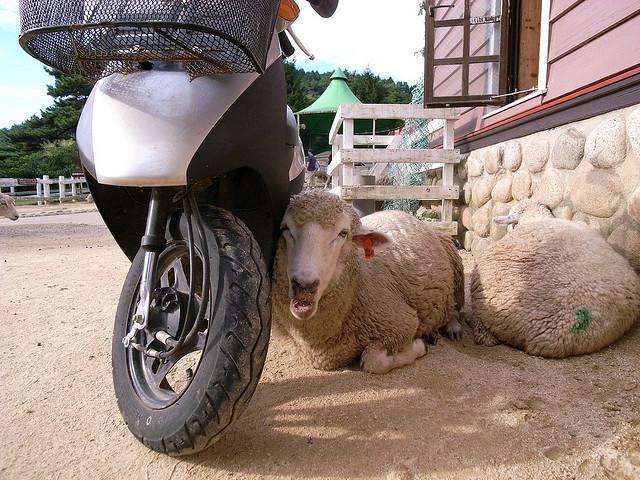How many sheep are there?
Give a very brief answer. 2. 